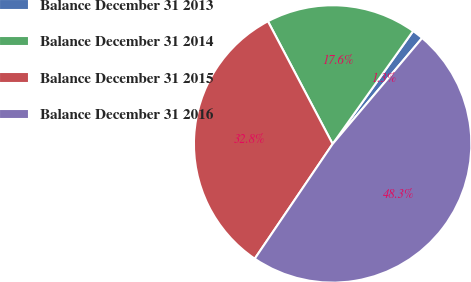Convert chart to OTSL. <chart><loc_0><loc_0><loc_500><loc_500><pie_chart><fcel>Balance December 31 2013<fcel>Balance December 31 2014<fcel>Balance December 31 2015<fcel>Balance December 31 2016<nl><fcel>1.31%<fcel>17.58%<fcel>32.78%<fcel>48.32%<nl></chart> 